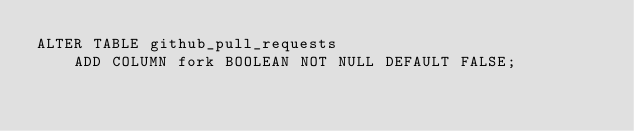Convert code to text. <code><loc_0><loc_0><loc_500><loc_500><_SQL_>ALTER TABLE github_pull_requests
    ADD COLUMN fork BOOLEAN NOT NULL DEFAULT FALSE;</code> 